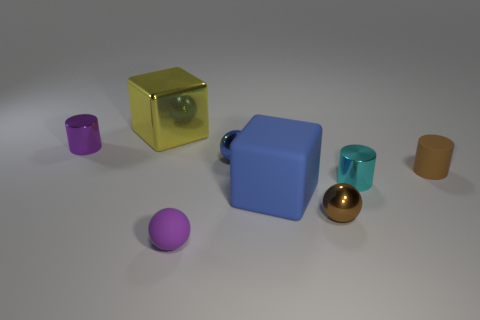Do the large yellow thing and the big thing that is on the right side of the tiny blue metal thing have the same shape?
Make the answer very short. Yes. Is there any other thing that is the same color as the large matte cube?
Give a very brief answer. Yes. Do the rubber thing that is behind the blue block and the cube that is on the left side of the small blue ball have the same color?
Your response must be concise. No. Is there a large green shiny cube?
Offer a terse response. No. Are there any big green cylinders made of the same material as the blue cube?
Your answer should be very brief. No. Is there any other thing that is made of the same material as the small brown cylinder?
Ensure brevity in your answer.  Yes. What is the color of the rubber cube?
Offer a terse response. Blue. What shape is the thing that is the same color as the small matte ball?
Ensure brevity in your answer.  Cylinder. What color is the rubber sphere that is the same size as the blue metallic object?
Ensure brevity in your answer.  Purple. How many rubber things are either tiny brown balls or cylinders?
Your response must be concise. 1. 